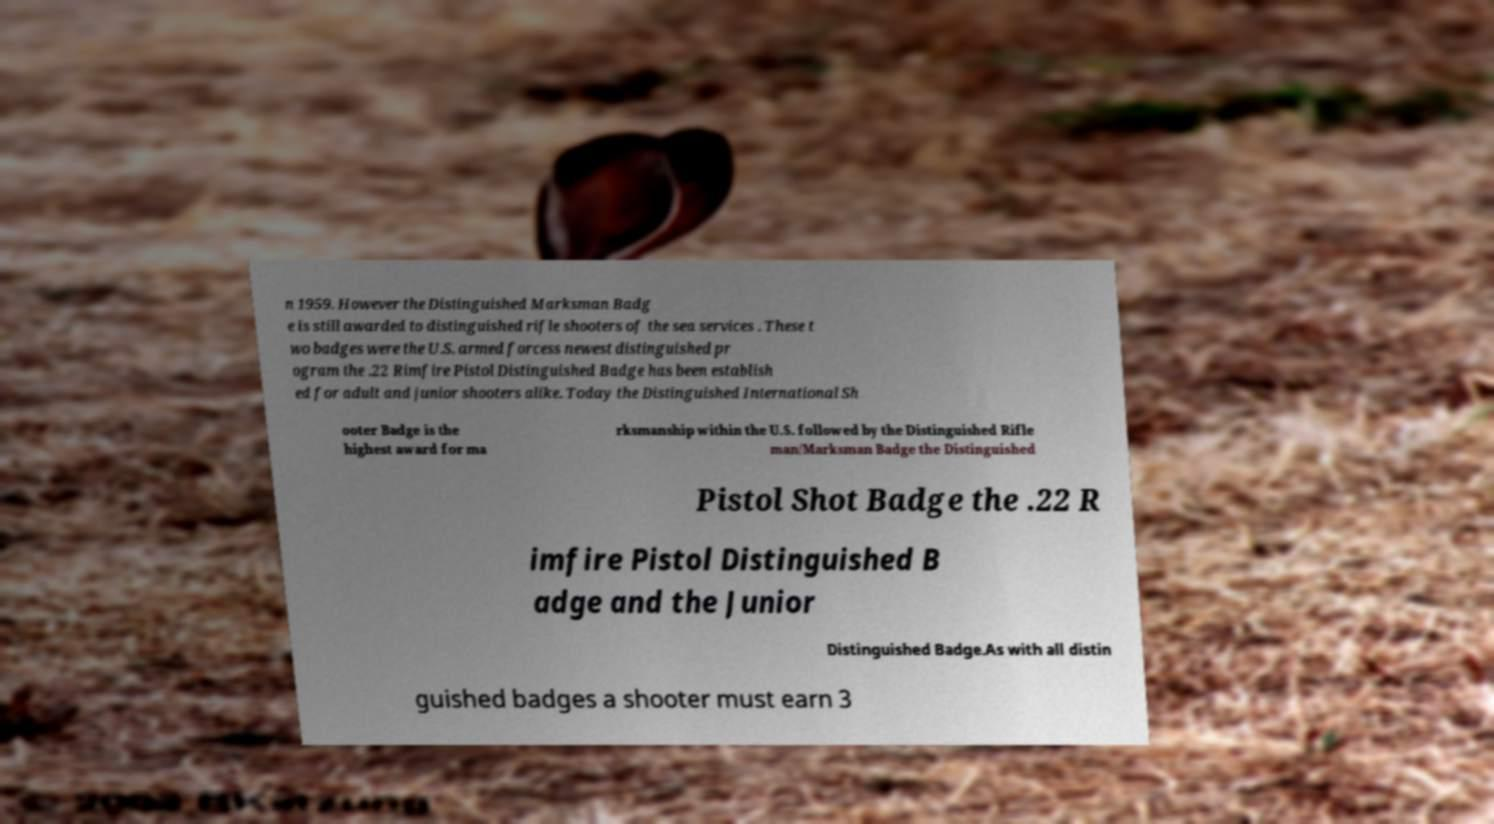Please identify and transcribe the text found in this image. n 1959. However the Distinguished Marksman Badg e is still awarded to distinguished rifle shooters of the sea services . These t wo badges were the U.S. armed forcess newest distinguished pr ogram the .22 Rimfire Pistol Distinguished Badge has been establish ed for adult and junior shooters alike. Today the Distinguished International Sh ooter Badge is the highest award for ma rksmanship within the U.S. followed by the Distinguished Rifle man/Marksman Badge the Distinguished Pistol Shot Badge the .22 R imfire Pistol Distinguished B adge and the Junior Distinguished Badge.As with all distin guished badges a shooter must earn 3 